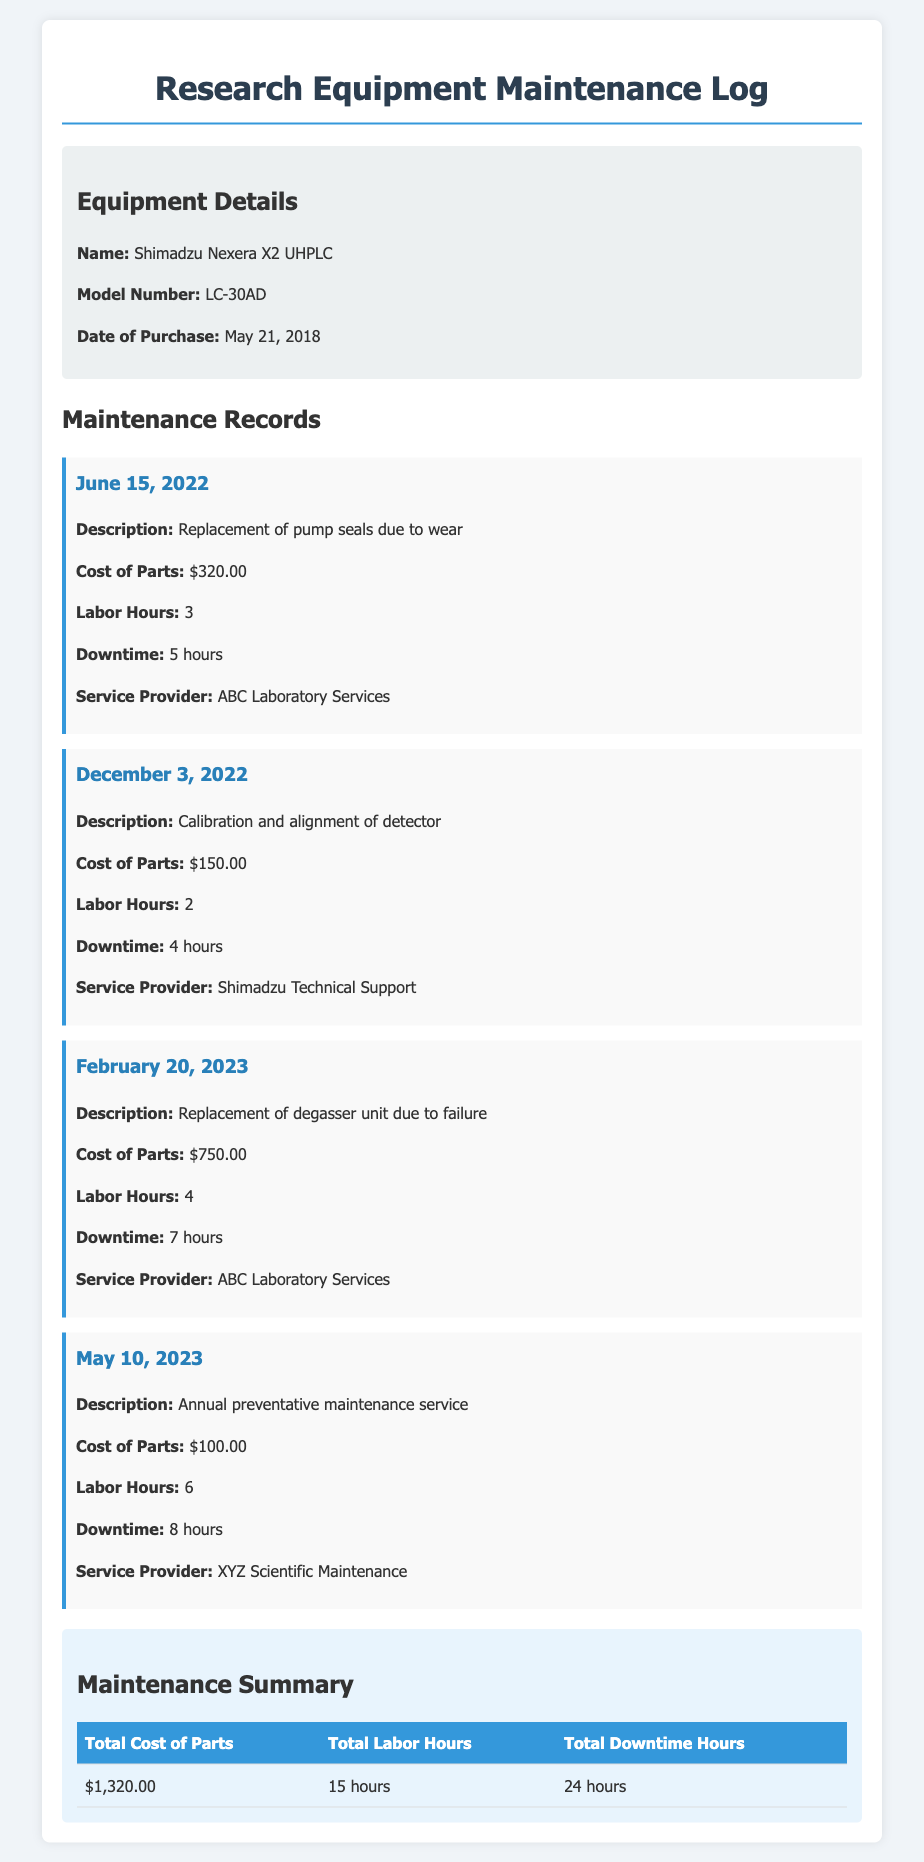What is the model number of the equipment? The model number is specified in the equipment details section of the document.
Answer: LC-30AD What was the cost of parts for the degasser unit replacement? This cost is detailed in the maintenance record for February 20, 2023.
Answer: $750.00 How long was the downtime for the annual preventative maintenance service? The downtime is noted in the maintenance record for May 10, 2023.
Answer: 8 hours What is the total cost of parts for all maintenance records? The total is calculated in the maintenance summary table, summing all individual costs.
Answer: $1,320.00 Which service provider performed the calibration and alignment of the detector? The service provider is mentioned in the maintenance record for December 3, 2022.
Answer: Shimadzu Technical Support What is the total number of labor hours recorded in the maintenance log? This total is provided in the maintenance summary table, adding the labor hours from all records.
Answer: 15 hours What was the description of the maintenance performed on June 15, 2022? This description is found in the corresponding maintenance record.
Answer: Replacement of pump seals due to wear Which month did the last recorded maintenance occur? The month is indicated in the date of the last maintenance record.
Answer: May How many total hours of downtime are recorded? The total is provided in the maintenance summary table, calculated from individual downtimes.
Answer: 24 hours 